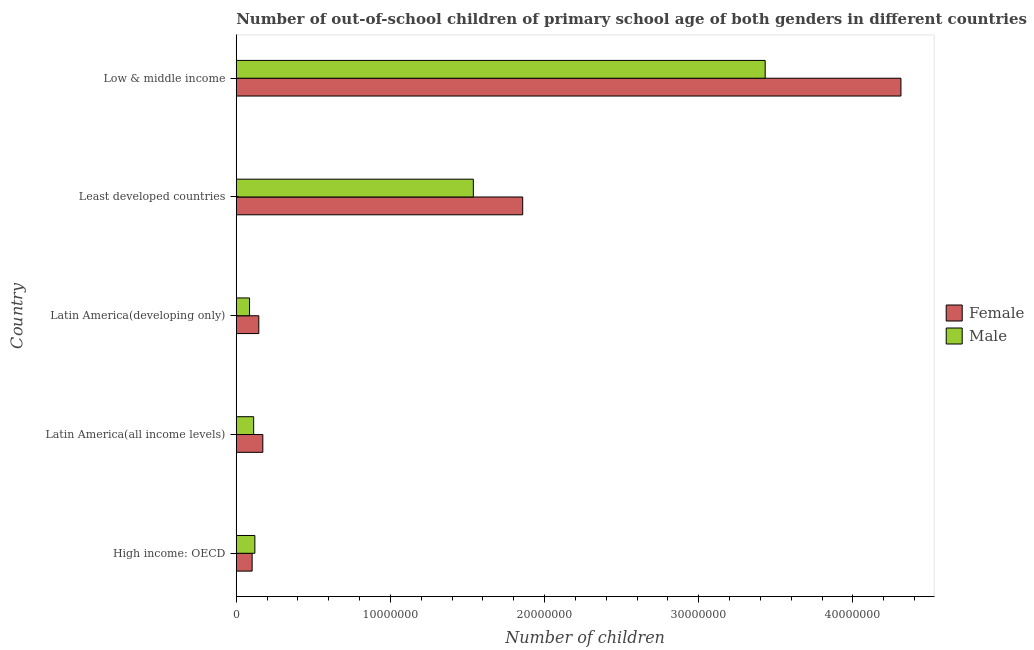How many different coloured bars are there?
Offer a very short reply. 2. Are the number of bars per tick equal to the number of legend labels?
Offer a very short reply. Yes. Are the number of bars on each tick of the Y-axis equal?
Your answer should be very brief. Yes. How many bars are there on the 5th tick from the bottom?
Provide a succinct answer. 2. What is the label of the 2nd group of bars from the top?
Provide a short and direct response. Least developed countries. What is the number of male out-of-school students in Latin America(all income levels)?
Provide a short and direct response. 1.13e+06. Across all countries, what is the maximum number of male out-of-school students?
Your answer should be compact. 3.43e+07. Across all countries, what is the minimum number of male out-of-school students?
Your answer should be very brief. 8.62e+05. In which country was the number of female out-of-school students minimum?
Your response must be concise. High income: OECD. What is the total number of female out-of-school students in the graph?
Give a very brief answer. 6.59e+07. What is the difference between the number of male out-of-school students in High income: OECD and that in Latin America(all income levels)?
Keep it short and to the point. 7.74e+04. What is the difference between the number of female out-of-school students in Low & middle income and the number of male out-of-school students in High income: OECD?
Make the answer very short. 4.19e+07. What is the average number of female out-of-school students per country?
Your answer should be compact. 1.32e+07. What is the difference between the number of male out-of-school students and number of female out-of-school students in Latin America(developing only)?
Your response must be concise. -6.01e+05. What is the ratio of the number of female out-of-school students in High income: OECD to that in Least developed countries?
Offer a very short reply. 0.06. What is the difference between the highest and the second highest number of female out-of-school students?
Make the answer very short. 2.45e+07. What is the difference between the highest and the lowest number of male out-of-school students?
Your answer should be very brief. 3.34e+07. Is the sum of the number of male out-of-school students in High income: OECD and Latin America(developing only) greater than the maximum number of female out-of-school students across all countries?
Ensure brevity in your answer.  No. What does the 1st bar from the top in High income: OECD represents?
Provide a short and direct response. Male. Are all the bars in the graph horizontal?
Your response must be concise. Yes. How many countries are there in the graph?
Offer a terse response. 5. Are the values on the major ticks of X-axis written in scientific E-notation?
Offer a terse response. No. Does the graph contain any zero values?
Offer a terse response. No. How many legend labels are there?
Your answer should be compact. 2. How are the legend labels stacked?
Offer a terse response. Vertical. What is the title of the graph?
Give a very brief answer. Number of out-of-school children of primary school age of both genders in different countries. Does "Savings" appear as one of the legend labels in the graph?
Give a very brief answer. No. What is the label or title of the X-axis?
Give a very brief answer. Number of children. What is the Number of children in Female in High income: OECD?
Ensure brevity in your answer.  1.03e+06. What is the Number of children in Male in High income: OECD?
Keep it short and to the point. 1.21e+06. What is the Number of children in Female in Latin America(all income levels)?
Give a very brief answer. 1.72e+06. What is the Number of children in Male in Latin America(all income levels)?
Make the answer very short. 1.13e+06. What is the Number of children of Female in Latin America(developing only)?
Give a very brief answer. 1.46e+06. What is the Number of children of Male in Latin America(developing only)?
Offer a terse response. 8.62e+05. What is the Number of children in Female in Least developed countries?
Make the answer very short. 1.86e+07. What is the Number of children of Male in Least developed countries?
Offer a terse response. 1.54e+07. What is the Number of children of Female in Low & middle income?
Your answer should be very brief. 4.31e+07. What is the Number of children of Male in Low & middle income?
Keep it short and to the point. 3.43e+07. Across all countries, what is the maximum Number of children in Female?
Provide a short and direct response. 4.31e+07. Across all countries, what is the maximum Number of children in Male?
Your answer should be very brief. 3.43e+07. Across all countries, what is the minimum Number of children in Female?
Your answer should be very brief. 1.03e+06. Across all countries, what is the minimum Number of children in Male?
Your response must be concise. 8.62e+05. What is the total Number of children of Female in the graph?
Ensure brevity in your answer.  6.59e+07. What is the total Number of children of Male in the graph?
Your answer should be very brief. 5.29e+07. What is the difference between the Number of children of Female in High income: OECD and that in Latin America(all income levels)?
Offer a terse response. -6.94e+05. What is the difference between the Number of children of Male in High income: OECD and that in Latin America(all income levels)?
Offer a very short reply. 7.74e+04. What is the difference between the Number of children of Female in High income: OECD and that in Latin America(developing only)?
Offer a terse response. -4.33e+05. What is the difference between the Number of children of Male in High income: OECD and that in Latin America(developing only)?
Give a very brief answer. 3.45e+05. What is the difference between the Number of children in Female in High income: OECD and that in Least developed countries?
Your response must be concise. -1.76e+07. What is the difference between the Number of children of Male in High income: OECD and that in Least developed countries?
Offer a terse response. -1.42e+07. What is the difference between the Number of children of Female in High income: OECD and that in Low & middle income?
Provide a short and direct response. -4.21e+07. What is the difference between the Number of children in Male in High income: OECD and that in Low & middle income?
Ensure brevity in your answer.  -3.31e+07. What is the difference between the Number of children in Female in Latin America(all income levels) and that in Latin America(developing only)?
Your answer should be very brief. 2.61e+05. What is the difference between the Number of children of Male in Latin America(all income levels) and that in Latin America(developing only)?
Your answer should be very brief. 2.68e+05. What is the difference between the Number of children in Female in Latin America(all income levels) and that in Least developed countries?
Make the answer very short. -1.69e+07. What is the difference between the Number of children in Male in Latin America(all income levels) and that in Least developed countries?
Offer a terse response. -1.42e+07. What is the difference between the Number of children of Female in Latin America(all income levels) and that in Low & middle income?
Make the answer very short. -4.14e+07. What is the difference between the Number of children in Male in Latin America(all income levels) and that in Low & middle income?
Keep it short and to the point. -3.32e+07. What is the difference between the Number of children in Female in Latin America(developing only) and that in Least developed countries?
Give a very brief answer. -1.71e+07. What is the difference between the Number of children of Male in Latin America(developing only) and that in Least developed countries?
Your answer should be very brief. -1.45e+07. What is the difference between the Number of children of Female in Latin America(developing only) and that in Low & middle income?
Make the answer very short. -4.17e+07. What is the difference between the Number of children in Male in Latin America(developing only) and that in Low & middle income?
Provide a short and direct response. -3.34e+07. What is the difference between the Number of children in Female in Least developed countries and that in Low & middle income?
Ensure brevity in your answer.  -2.45e+07. What is the difference between the Number of children of Male in Least developed countries and that in Low & middle income?
Offer a very short reply. -1.89e+07. What is the difference between the Number of children of Female in High income: OECD and the Number of children of Male in Latin America(all income levels)?
Your response must be concise. -9.96e+04. What is the difference between the Number of children in Female in High income: OECD and the Number of children in Male in Latin America(developing only)?
Provide a short and direct response. 1.68e+05. What is the difference between the Number of children in Female in High income: OECD and the Number of children in Male in Least developed countries?
Offer a terse response. -1.43e+07. What is the difference between the Number of children of Female in High income: OECD and the Number of children of Male in Low & middle income?
Your answer should be compact. -3.33e+07. What is the difference between the Number of children of Female in Latin America(all income levels) and the Number of children of Male in Latin America(developing only)?
Keep it short and to the point. 8.62e+05. What is the difference between the Number of children in Female in Latin America(all income levels) and the Number of children in Male in Least developed countries?
Provide a short and direct response. -1.37e+07. What is the difference between the Number of children in Female in Latin America(all income levels) and the Number of children in Male in Low & middle income?
Make the answer very short. -3.26e+07. What is the difference between the Number of children of Female in Latin America(developing only) and the Number of children of Male in Least developed countries?
Offer a terse response. -1.39e+07. What is the difference between the Number of children in Female in Latin America(developing only) and the Number of children in Male in Low & middle income?
Your answer should be very brief. -3.28e+07. What is the difference between the Number of children of Female in Least developed countries and the Number of children of Male in Low & middle income?
Give a very brief answer. -1.57e+07. What is the average Number of children of Female per country?
Keep it short and to the point. 1.32e+07. What is the average Number of children in Male per country?
Provide a succinct answer. 1.06e+07. What is the difference between the Number of children of Female and Number of children of Male in High income: OECD?
Your answer should be compact. -1.77e+05. What is the difference between the Number of children in Female and Number of children in Male in Latin America(all income levels)?
Provide a succinct answer. 5.95e+05. What is the difference between the Number of children in Female and Number of children in Male in Latin America(developing only)?
Give a very brief answer. 6.01e+05. What is the difference between the Number of children of Female and Number of children of Male in Least developed countries?
Ensure brevity in your answer.  3.20e+06. What is the difference between the Number of children in Female and Number of children in Male in Low & middle income?
Provide a succinct answer. 8.81e+06. What is the ratio of the Number of children in Female in High income: OECD to that in Latin America(all income levels)?
Provide a succinct answer. 0.6. What is the ratio of the Number of children in Male in High income: OECD to that in Latin America(all income levels)?
Offer a terse response. 1.07. What is the ratio of the Number of children of Female in High income: OECD to that in Latin America(developing only)?
Offer a terse response. 0.7. What is the ratio of the Number of children of Male in High income: OECD to that in Latin America(developing only)?
Ensure brevity in your answer.  1.4. What is the ratio of the Number of children in Female in High income: OECD to that in Least developed countries?
Your response must be concise. 0.06. What is the ratio of the Number of children in Male in High income: OECD to that in Least developed countries?
Your answer should be very brief. 0.08. What is the ratio of the Number of children in Female in High income: OECD to that in Low & middle income?
Provide a short and direct response. 0.02. What is the ratio of the Number of children in Male in High income: OECD to that in Low & middle income?
Your response must be concise. 0.04. What is the ratio of the Number of children in Female in Latin America(all income levels) to that in Latin America(developing only)?
Keep it short and to the point. 1.18. What is the ratio of the Number of children of Male in Latin America(all income levels) to that in Latin America(developing only)?
Your response must be concise. 1.31. What is the ratio of the Number of children of Female in Latin America(all income levels) to that in Least developed countries?
Ensure brevity in your answer.  0.09. What is the ratio of the Number of children in Male in Latin America(all income levels) to that in Least developed countries?
Your response must be concise. 0.07. What is the ratio of the Number of children in Female in Latin America(all income levels) to that in Low & middle income?
Give a very brief answer. 0.04. What is the ratio of the Number of children in Male in Latin America(all income levels) to that in Low & middle income?
Give a very brief answer. 0.03. What is the ratio of the Number of children in Female in Latin America(developing only) to that in Least developed countries?
Provide a short and direct response. 0.08. What is the ratio of the Number of children of Male in Latin America(developing only) to that in Least developed countries?
Provide a short and direct response. 0.06. What is the ratio of the Number of children of Female in Latin America(developing only) to that in Low & middle income?
Your answer should be compact. 0.03. What is the ratio of the Number of children in Male in Latin America(developing only) to that in Low & middle income?
Keep it short and to the point. 0.03. What is the ratio of the Number of children in Female in Least developed countries to that in Low & middle income?
Your answer should be compact. 0.43. What is the ratio of the Number of children in Male in Least developed countries to that in Low & middle income?
Your answer should be compact. 0.45. What is the difference between the highest and the second highest Number of children in Female?
Your answer should be very brief. 2.45e+07. What is the difference between the highest and the second highest Number of children of Male?
Your answer should be very brief. 1.89e+07. What is the difference between the highest and the lowest Number of children of Female?
Your answer should be very brief. 4.21e+07. What is the difference between the highest and the lowest Number of children of Male?
Give a very brief answer. 3.34e+07. 